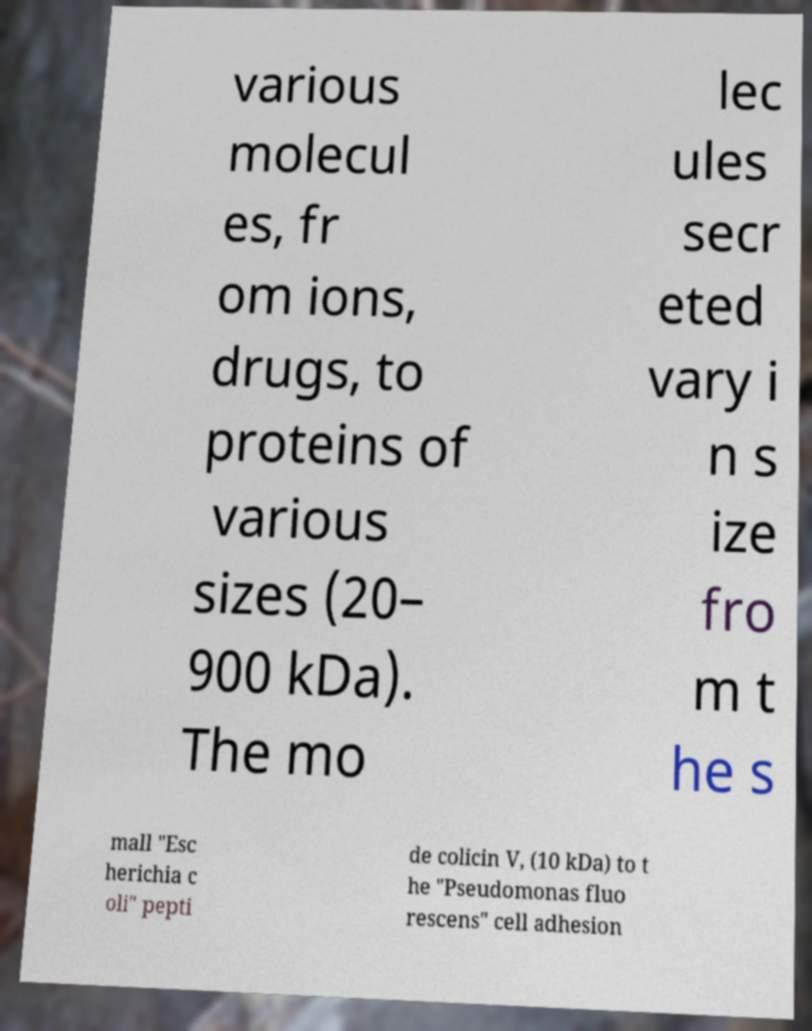Can you accurately transcribe the text from the provided image for me? various molecul es, fr om ions, drugs, to proteins of various sizes (20– 900 kDa). The mo lec ules secr eted vary i n s ize fro m t he s mall "Esc herichia c oli" pepti de colicin V, (10 kDa) to t he "Pseudomonas fluo rescens" cell adhesion 